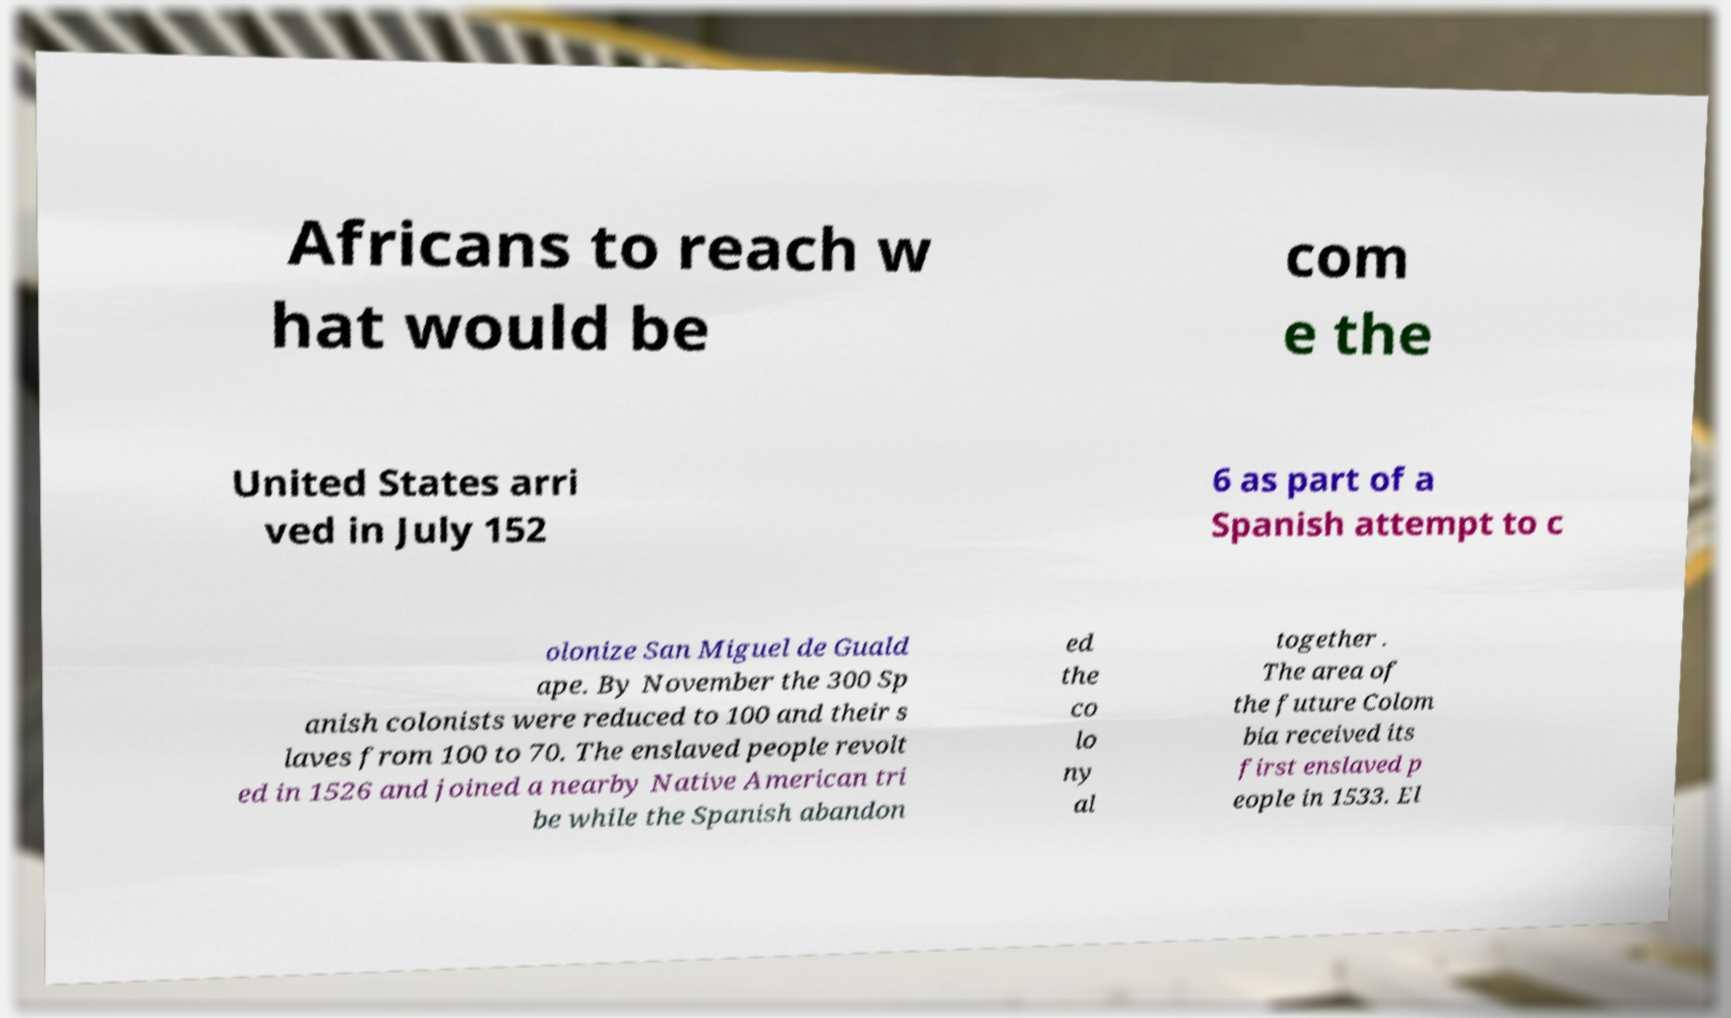Could you extract and type out the text from this image? Africans to reach w hat would be com e the United States arri ved in July 152 6 as part of a Spanish attempt to c olonize San Miguel de Guald ape. By November the 300 Sp anish colonists were reduced to 100 and their s laves from 100 to 70. The enslaved people revolt ed in 1526 and joined a nearby Native American tri be while the Spanish abandon ed the co lo ny al together . The area of the future Colom bia received its first enslaved p eople in 1533. El 